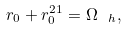<formula> <loc_0><loc_0><loc_500><loc_500>r _ { 0 } + r _ { 0 } ^ { 2 1 } = \Omega _ { \ h } ,</formula> 